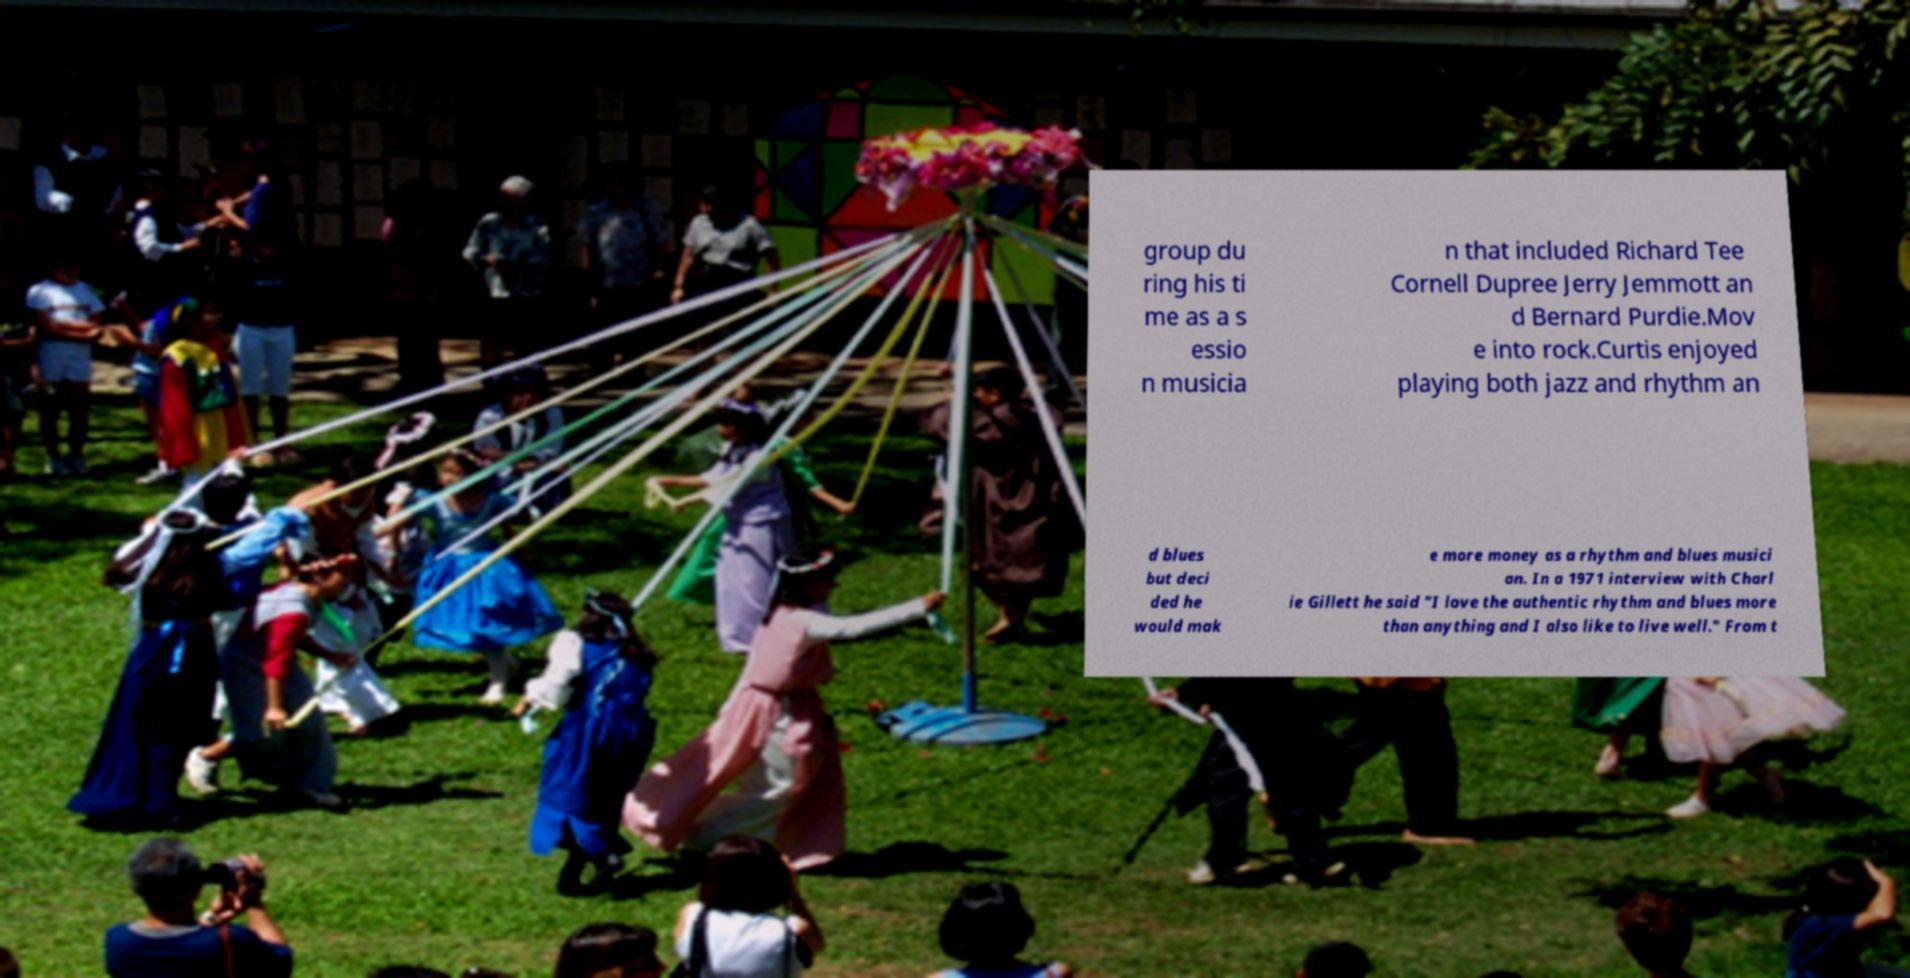Please identify and transcribe the text found in this image. group du ring his ti me as a s essio n musicia n that included Richard Tee Cornell Dupree Jerry Jemmott an d Bernard Purdie.Mov e into rock.Curtis enjoyed playing both jazz and rhythm an d blues but deci ded he would mak e more money as a rhythm and blues musici an. In a 1971 interview with Charl ie Gillett he said "I love the authentic rhythm and blues more than anything and I also like to live well." From t 